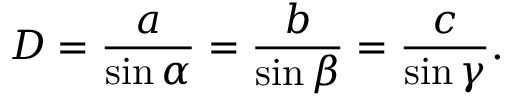Convert formula to latex. <formula><loc_0><loc_0><loc_500><loc_500>D = { \frac { a } { \sin \alpha } } = { \frac { b } { \sin \beta } } = { \frac { c } { \sin \gamma } } .</formula> 